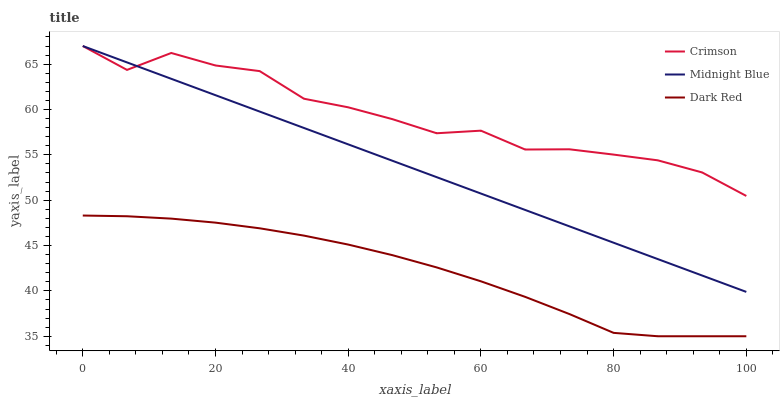Does Dark Red have the minimum area under the curve?
Answer yes or no. Yes. Does Crimson have the maximum area under the curve?
Answer yes or no. Yes. Does Midnight Blue have the minimum area under the curve?
Answer yes or no. No. Does Midnight Blue have the maximum area under the curve?
Answer yes or no. No. Is Midnight Blue the smoothest?
Answer yes or no. Yes. Is Crimson the roughest?
Answer yes or no. Yes. Is Dark Red the smoothest?
Answer yes or no. No. Is Dark Red the roughest?
Answer yes or no. No. Does Dark Red have the lowest value?
Answer yes or no. Yes. Does Midnight Blue have the lowest value?
Answer yes or no. No. Does Midnight Blue have the highest value?
Answer yes or no. Yes. Does Dark Red have the highest value?
Answer yes or no. No. Is Dark Red less than Midnight Blue?
Answer yes or no. Yes. Is Midnight Blue greater than Dark Red?
Answer yes or no. Yes. Does Midnight Blue intersect Crimson?
Answer yes or no. Yes. Is Midnight Blue less than Crimson?
Answer yes or no. No. Is Midnight Blue greater than Crimson?
Answer yes or no. No. Does Dark Red intersect Midnight Blue?
Answer yes or no. No. 